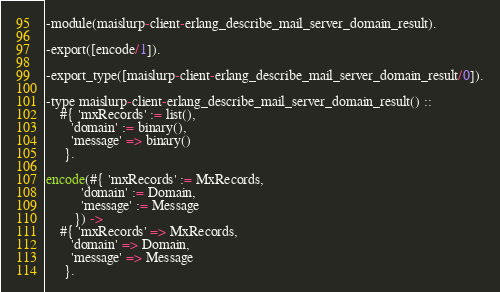Convert code to text. <code><loc_0><loc_0><loc_500><loc_500><_Erlang_>-module(maislurp-client-erlang_describe_mail_server_domain_result).

-export([encode/1]).

-export_type([maislurp-client-erlang_describe_mail_server_domain_result/0]).

-type maislurp-client-erlang_describe_mail_server_domain_result() ::
    #{ 'mxRecords' := list(),
       'domain' := binary(),
       'message' => binary()
     }.

encode(#{ 'mxRecords' := MxRecords,
          'domain' := Domain,
          'message' := Message
        }) ->
    #{ 'mxRecords' => MxRecords,
       'domain' => Domain,
       'message' => Message
     }.
</code> 